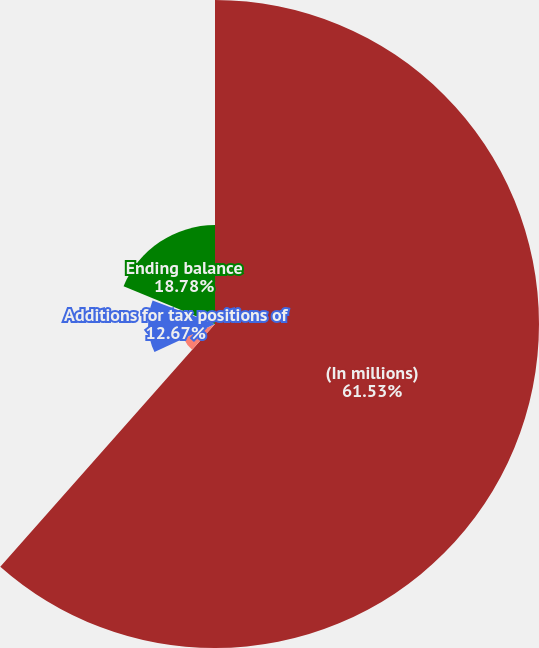Convert chart to OTSL. <chart><loc_0><loc_0><loc_500><loc_500><pie_chart><fcel>(In millions)<fcel>Beginning balance<fcel>Additions for tax positions of<fcel>Reductions for tax positions<fcel>Ending balance<nl><fcel>61.53%<fcel>6.56%<fcel>12.67%<fcel>0.46%<fcel>18.78%<nl></chart> 